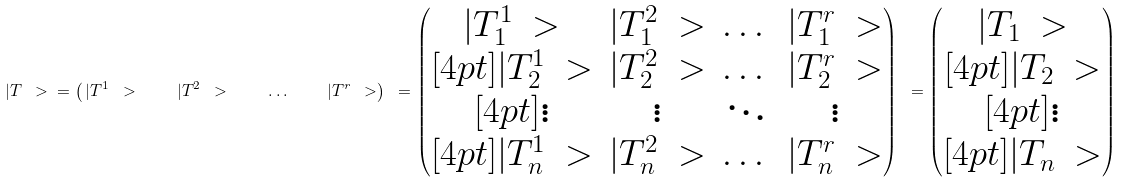Convert formula to latex. <formula><loc_0><loc_0><loc_500><loc_500>| T \ > \ = \left ( \, | T ^ { 1 } \ > \quad | T ^ { 2 } \ > \quad \dots \quad | T ^ { r } \ > \right ) \ = \begin{pmatrix} | T _ { 1 } ^ { 1 } \ > & | T _ { 1 } ^ { 2 } \ > & \dots & | T _ { 1 } ^ { r } \ > \\ [ 4 p t ] | T _ { 2 } ^ { 1 } \ > & | T _ { 2 } ^ { 2 } \ > & \dots & | T _ { 2 } ^ { r } \ > \\ [ 4 p t ] \vdots & \vdots & \ddots & \vdots \\ [ 4 p t ] | T _ { n } ^ { 1 } \ > & | T _ { n } ^ { 2 } \ > & \dots & | T _ { n } ^ { r } \ > \end{pmatrix} \ = \begin{pmatrix} | T _ { 1 } \ > \\ [ 4 p t ] | T _ { 2 } \ > \\ [ 4 p t ] \vdots \\ [ 4 p t ] | T _ { n } \ > \end{pmatrix}</formula> 